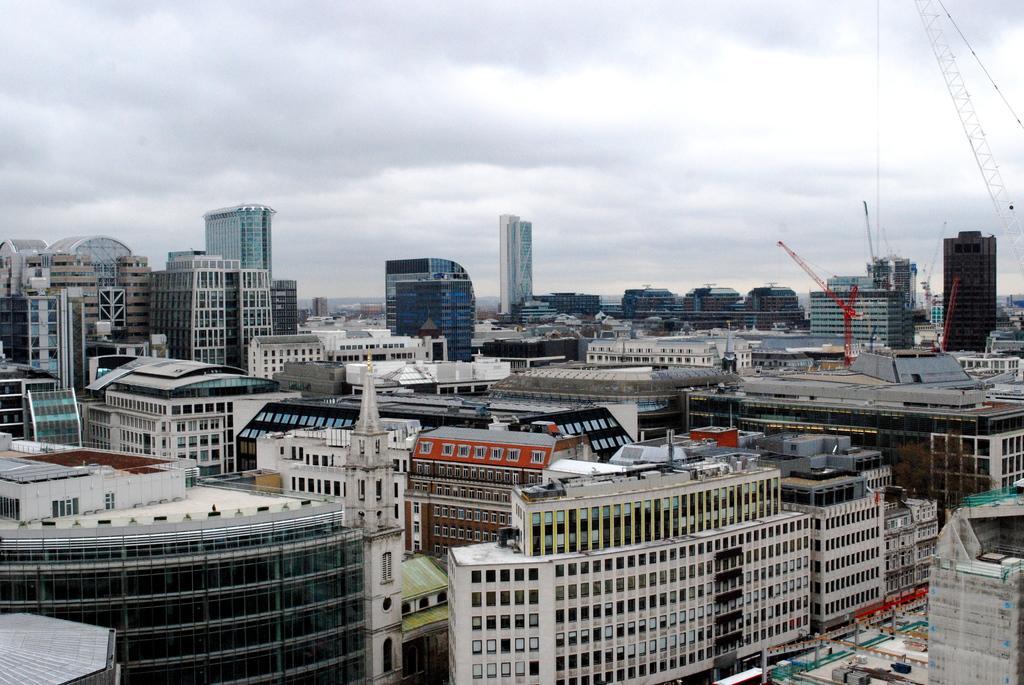Please provide a concise description of this image. As we can see in the image there are buildings, sky and clouds. 